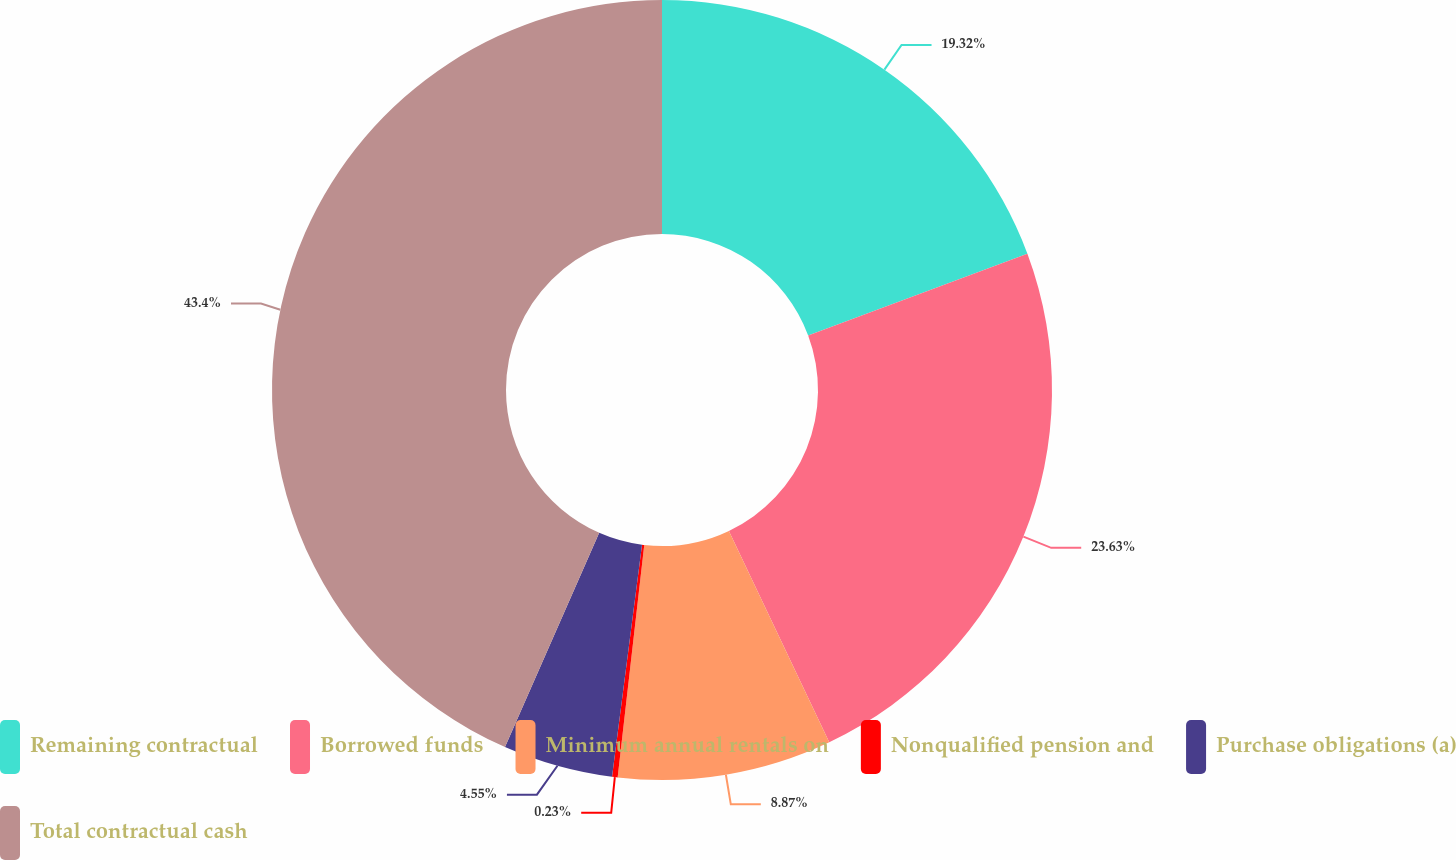Convert chart to OTSL. <chart><loc_0><loc_0><loc_500><loc_500><pie_chart><fcel>Remaining contractual<fcel>Borrowed funds<fcel>Minimum annual rentals on<fcel>Nonqualified pension and<fcel>Purchase obligations (a)<fcel>Total contractual cash<nl><fcel>19.32%<fcel>23.63%<fcel>8.87%<fcel>0.23%<fcel>4.55%<fcel>43.41%<nl></chart> 